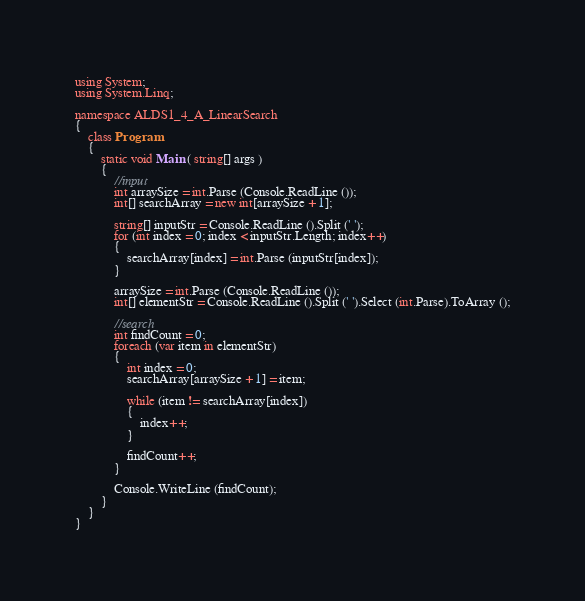Convert code to text. <code><loc_0><loc_0><loc_500><loc_500><_C#_>using System;
using System.Linq;

namespace ALDS1_4_A_LinearSearch
{
	class Program
	{
		static void Main ( string[] args )
		{
			//input
			int arraySize = int.Parse (Console.ReadLine ());
			int[] searchArray = new int[arraySize + 1];

			string[] inputStr = Console.ReadLine ().Split (' ');
			for (int index = 0; index < inputStr.Length; index++)
			{
				searchArray[index] = int.Parse (inputStr[index]);
			}

			arraySize = int.Parse (Console.ReadLine ());
			int[] elementStr = Console.ReadLine ().Split (' ').Select (int.Parse).ToArray ();

			//search
			int findCount = 0;
			foreach (var item in elementStr)
			{
				int index = 0;
				searchArray[arraySize + 1] = item;

				while (item != searchArray[index])
				{
					index++;
				}

				findCount++;
			}

			Console.WriteLine (findCount);
		}
	}
}</code> 